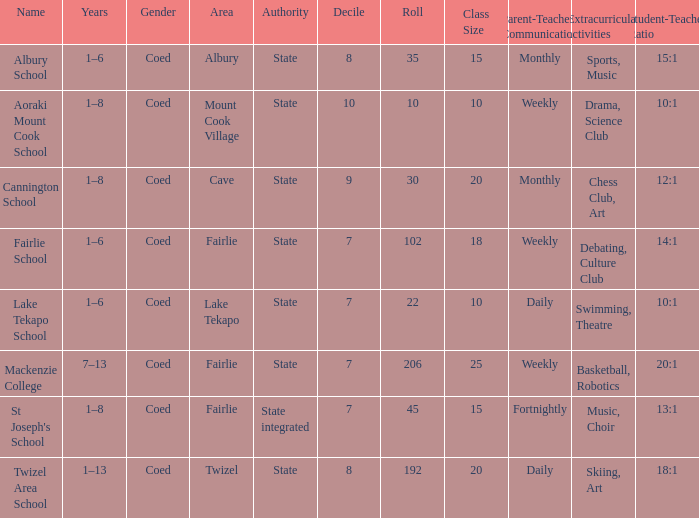What is the total Decile that has a state authority, fairlie area and roll smarter than 206? 1.0. I'm looking to parse the entire table for insights. Could you assist me with that? {'header': ['Name', 'Years', 'Gender', 'Area', 'Authority', 'Decile', 'Roll', 'Class Size', 'Parent-Teacher Communication', 'Extracurricular activities', 'Student-Teacher Ratio '], 'rows': [['Albury School', '1–6', 'Coed', 'Albury', 'State', '8', '35', '15', 'Monthly', 'Sports, Music', '15:1'], ['Aoraki Mount Cook School', '1–8', 'Coed', 'Mount Cook Village', 'State', '10', '10', '10', 'Weekly', 'Drama, Science Club', '10:1'], ['Cannington School', '1–8', 'Coed', 'Cave', 'State', '9', '30', '20', 'Monthly', 'Chess Club, Art', '12:1'], ['Fairlie School', '1–6', 'Coed', 'Fairlie', 'State', '7', '102', '18', 'Weekly', 'Debating, Culture Club', '14:1'], ['Lake Tekapo School', '1–6', 'Coed', 'Lake Tekapo', 'State', '7', '22', '10', 'Daily', 'Swimming, Theatre', '10:1'], ['Mackenzie College', '7–13', 'Coed', 'Fairlie', 'State', '7', '206', '25', 'Weekly', 'Basketball, Robotics', '20:1'], ["St Joseph's School", '1–8', 'Coed', 'Fairlie', 'State integrated', '7', '45', '15', 'Fortnightly', 'Music, Choir', '13:1'], ['Twizel Area School', '1–13', 'Coed', 'Twizel', 'State', '8', '192', '20', 'Daily', 'Skiing, Art', '18:1']]} 